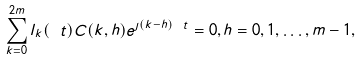Convert formula to latex. <formula><loc_0><loc_0><loc_500><loc_500>\sum _ { k = 0 } ^ { 2 m } l _ { k } ( \ t ) C ( k , h ) e ^ { \jmath ( k - h ) \ t } = 0 , h = 0 , 1 , \dots , m - 1 ,</formula> 